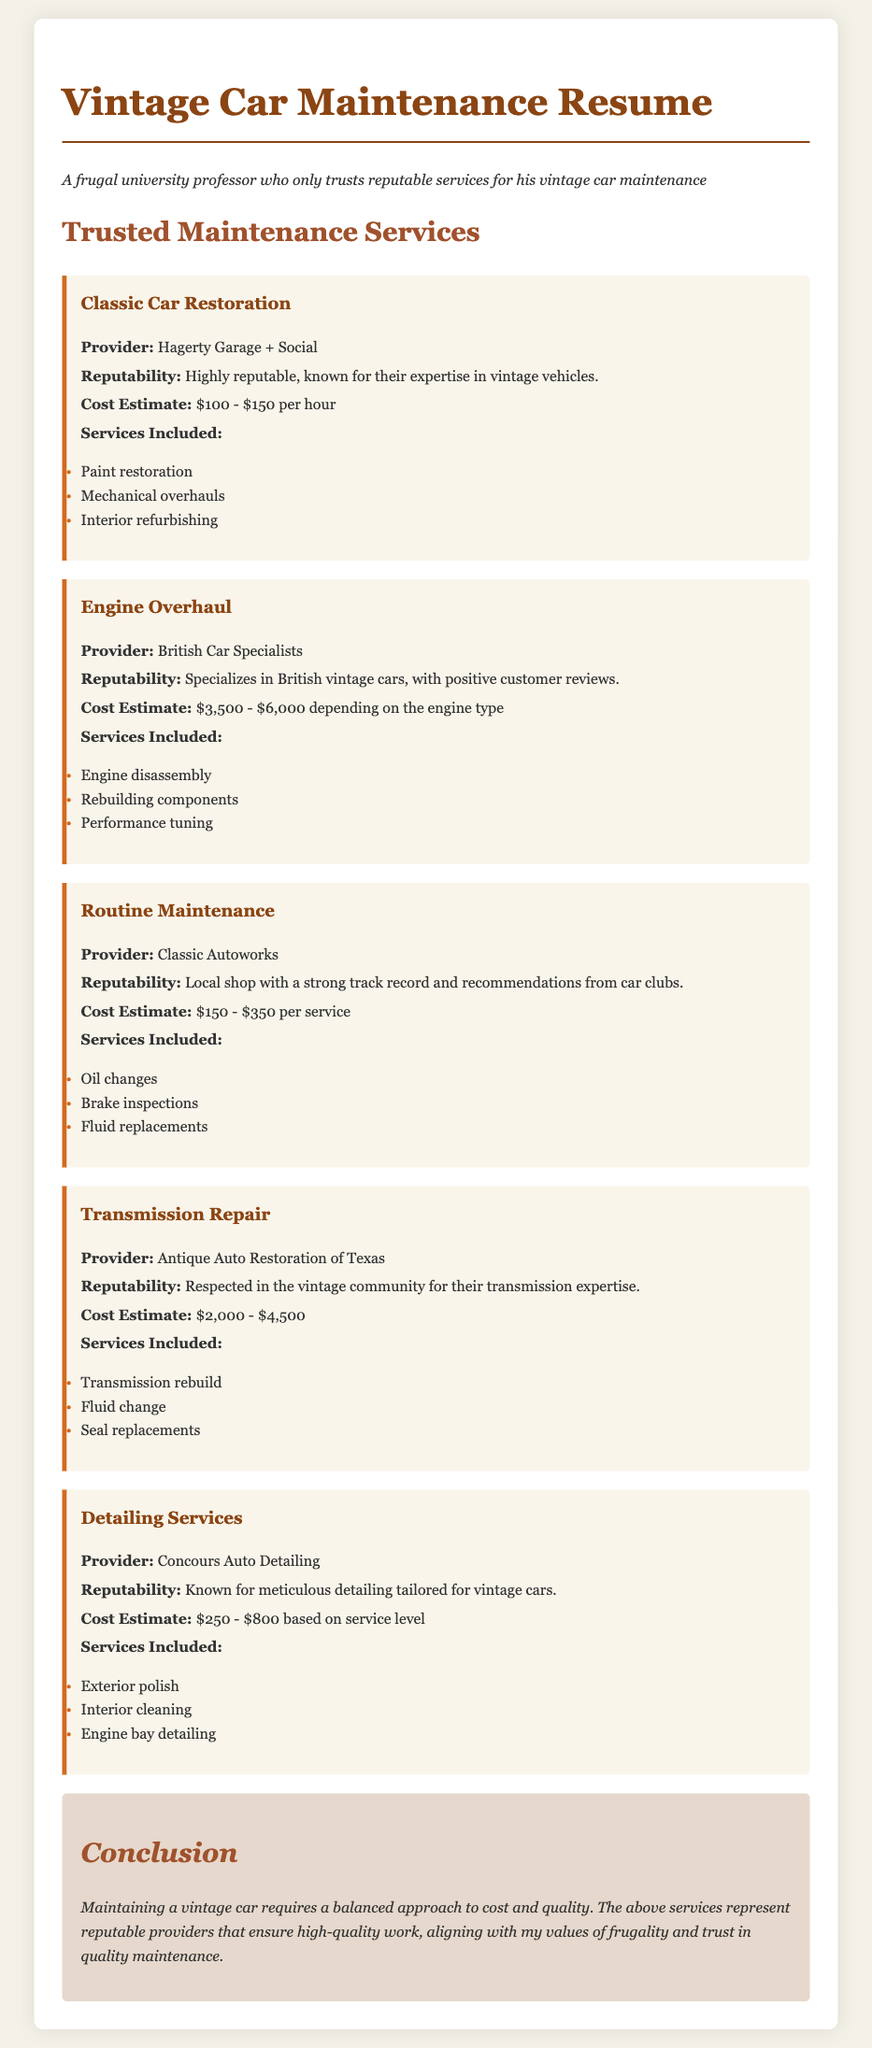What is the provider for detailing services? The provider for detailing services is Concours Auto Detailing.
Answer: Concours Auto Detailing What is the cost estimate range for engine overhaul? The cost estimate range for engine overhaul is $3,500 - $6,000 depending on the engine type.
Answer: $3,500 - $6,000 Which service provider specializes in British vintage cars? The service provider that specializes in British vintage cars is British Car Specialists.
Answer: British Car Specialists What is a service included in routine maintenance? A service included in routine maintenance is oil changes.
Answer: Oil changes What is the reputability of Antique Auto Restoration of Texas? The reputability of Antique Auto Restoration of Texas is respected in the vintage community for their transmission expertise.
Answer: Respected in the vintage community What is the highest cost estimate listed in the document? The highest cost estimate listed in the document is $800 for detailing services based on service level.
Answer: $800 How many services are included in Classic Car Restoration? The services included in Classic Car Restoration are three: paint restoration, mechanical overhauls, and interior refurbishing.
Answer: Three Which maintenance service has a local shop reputation? The maintenance service with a local shop reputation is Classic Autoworks.
Answer: Classic Autoworks What is the title of the conclusion section? The title of the conclusion section is Conclusion.
Answer: Conclusion 